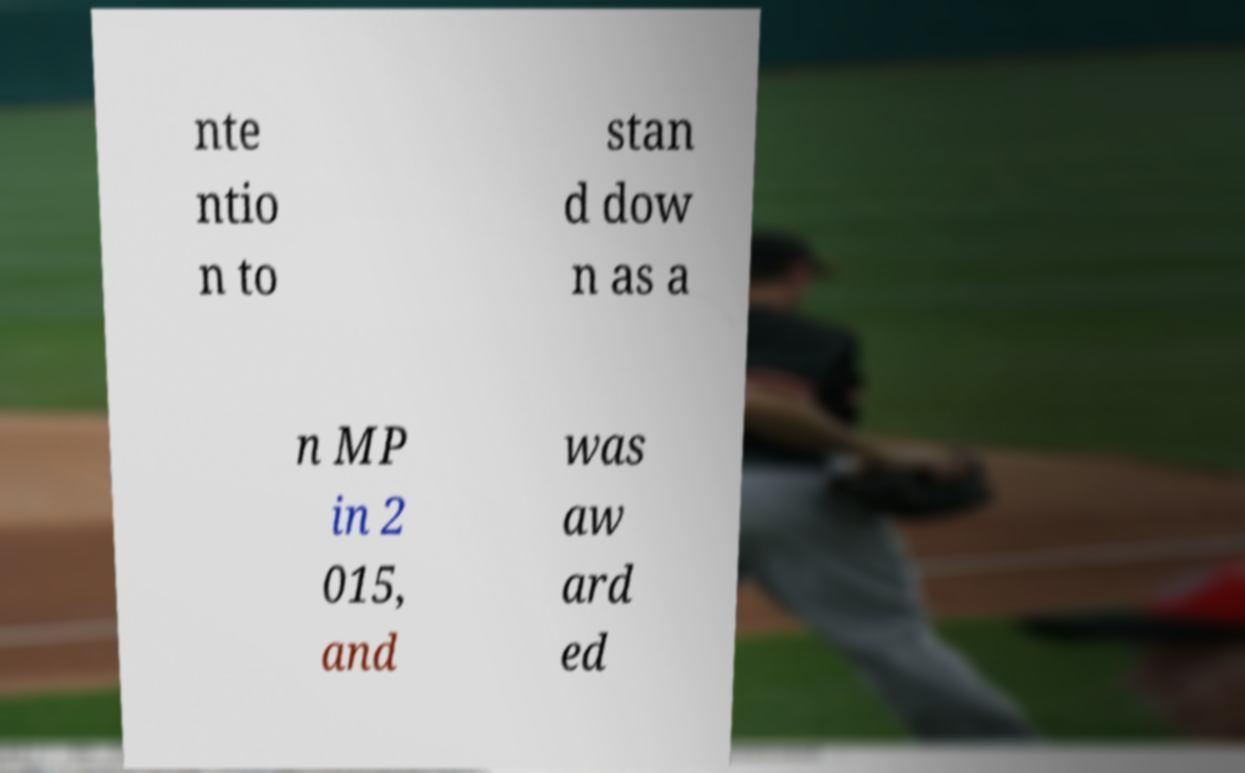Please identify and transcribe the text found in this image. nte ntio n to stan d dow n as a n MP in 2 015, and was aw ard ed 